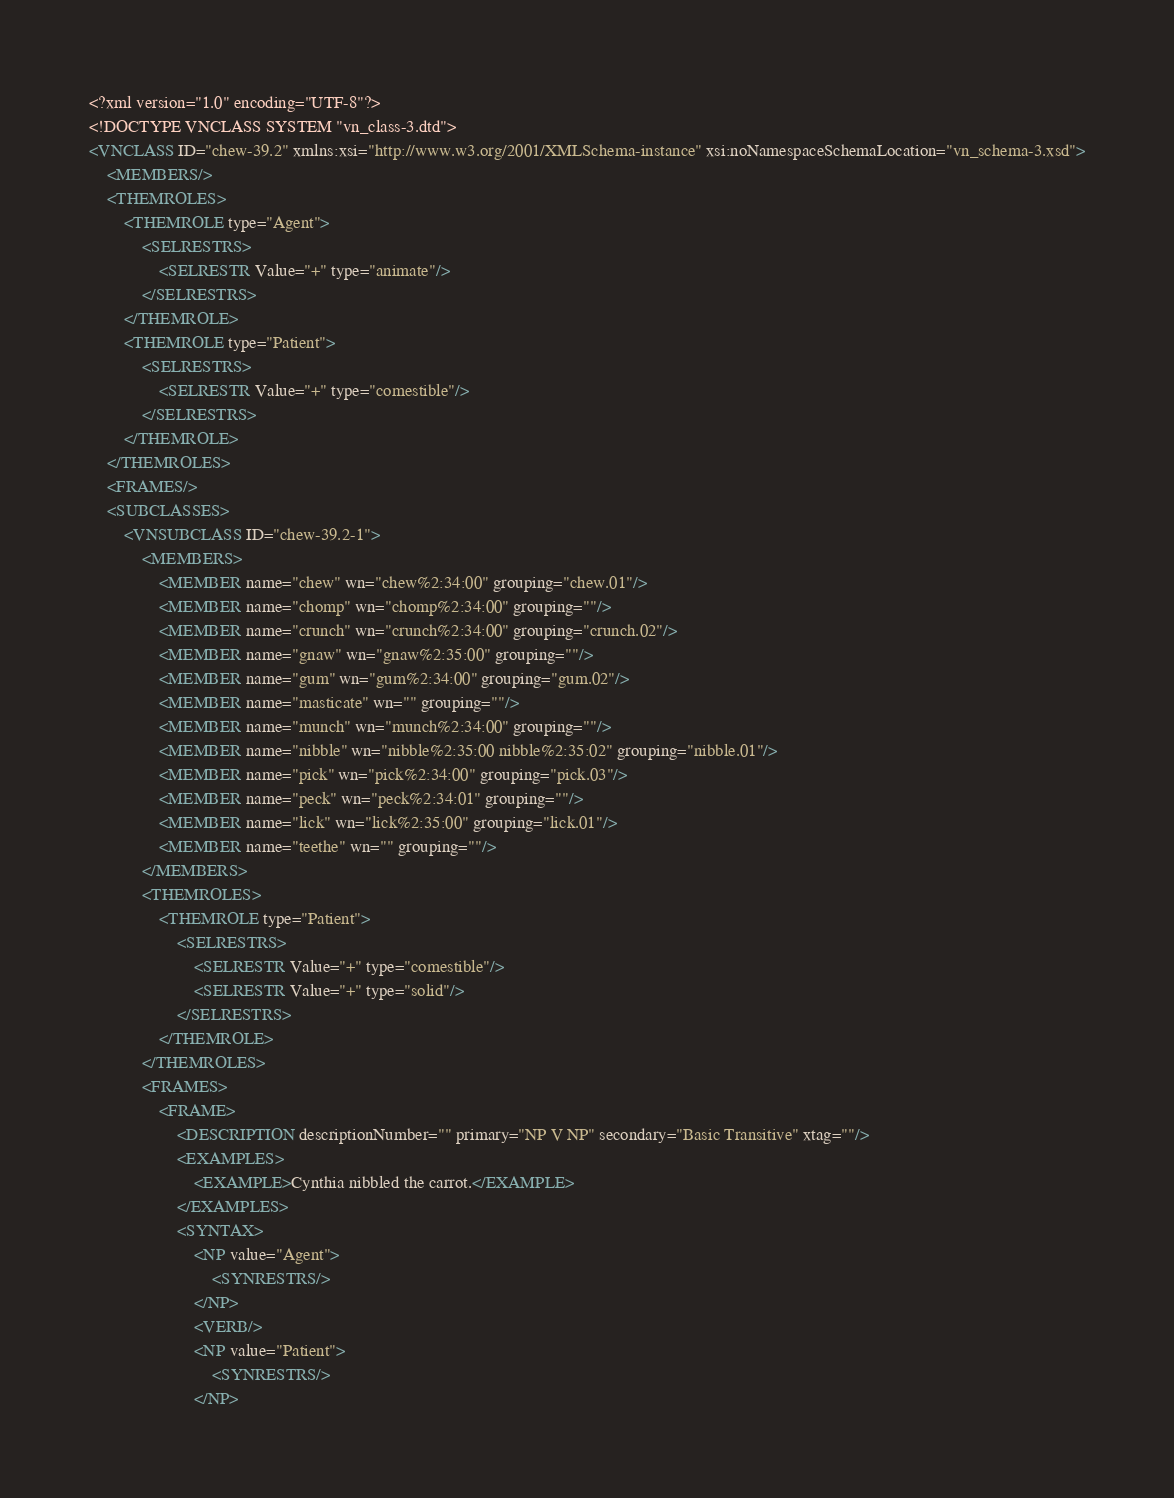<code> <loc_0><loc_0><loc_500><loc_500><_XML_><?xml version="1.0" encoding="UTF-8"?>
<!DOCTYPE VNCLASS SYSTEM "vn_class-3.dtd">
<VNCLASS ID="chew-39.2" xmlns:xsi="http://www.w3.org/2001/XMLSchema-instance" xsi:noNamespaceSchemaLocation="vn_schema-3.xsd">
    <MEMBERS/>
    <THEMROLES>
        <THEMROLE type="Agent">
            <SELRESTRS>
                <SELRESTR Value="+" type="animate"/>
            </SELRESTRS>
        </THEMROLE>
        <THEMROLE type="Patient">
            <SELRESTRS>
                <SELRESTR Value="+" type="comestible"/>
            </SELRESTRS>
        </THEMROLE>
    </THEMROLES>
    <FRAMES/>
    <SUBCLASSES>
        <VNSUBCLASS ID="chew-39.2-1">
            <MEMBERS>
                <MEMBER name="chew" wn="chew%2:34:00" grouping="chew.01"/>
                <MEMBER name="chomp" wn="chomp%2:34:00" grouping=""/>
                <MEMBER name="crunch" wn="crunch%2:34:00" grouping="crunch.02"/>
                <MEMBER name="gnaw" wn="gnaw%2:35:00" grouping=""/>
                <MEMBER name="gum" wn="gum%2:34:00" grouping="gum.02"/>
                <MEMBER name="masticate" wn="" grouping=""/>
                <MEMBER name="munch" wn="munch%2:34:00" grouping=""/>
                <MEMBER name="nibble" wn="nibble%2:35:00 nibble%2:35:02" grouping="nibble.01"/>
                <MEMBER name="pick" wn="pick%2:34:00" grouping="pick.03"/>
                <MEMBER name="peck" wn="peck%2:34:01" grouping=""/>
                <MEMBER name="lick" wn="lick%2:35:00" grouping="lick.01"/>
                <MEMBER name="teethe" wn="" grouping=""/>
            </MEMBERS>
            <THEMROLES>
                <THEMROLE type="Patient">
                    <SELRESTRS>
                        <SELRESTR Value="+" type="comestible"/>
                        <SELRESTR Value="+" type="solid"/>
                    </SELRESTRS>
                </THEMROLE>
            </THEMROLES>
            <FRAMES>
                <FRAME>
                    <DESCRIPTION descriptionNumber="" primary="NP V NP" secondary="Basic Transitive" xtag=""/>
                    <EXAMPLES>
                        <EXAMPLE>Cynthia nibbled the carrot.</EXAMPLE>
                    </EXAMPLES>
                    <SYNTAX>
                        <NP value="Agent">
                            <SYNRESTRS/>
                        </NP>
                        <VERB/>
                        <NP value="Patient">
                            <SYNRESTRS/>
                        </NP></code> 